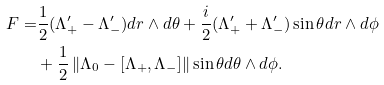Convert formula to latex. <formula><loc_0><loc_0><loc_500><loc_500>F = & \frac { 1 } { 2 } ( \Lambda _ { + } ^ { \prime } - \Lambda _ { - } ^ { \prime } ) d r \wedge d \theta + \frac { i } { 2 } ( \Lambda _ { + } ^ { \prime } + \Lambda _ { - } ^ { \prime } ) \sin \theta d r \wedge d \phi \\ & + \frac { 1 } { 2 } \left \| \Lambda _ { 0 } - [ \Lambda _ { + } , \Lambda _ { - } ] \right \| \sin \theta d \theta \wedge d \phi .</formula> 